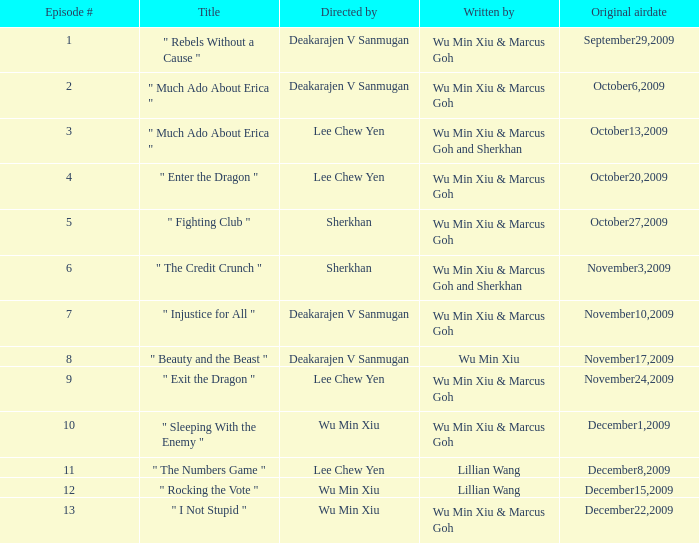What was the title for episode 2? " Much Ado About Erica ". 